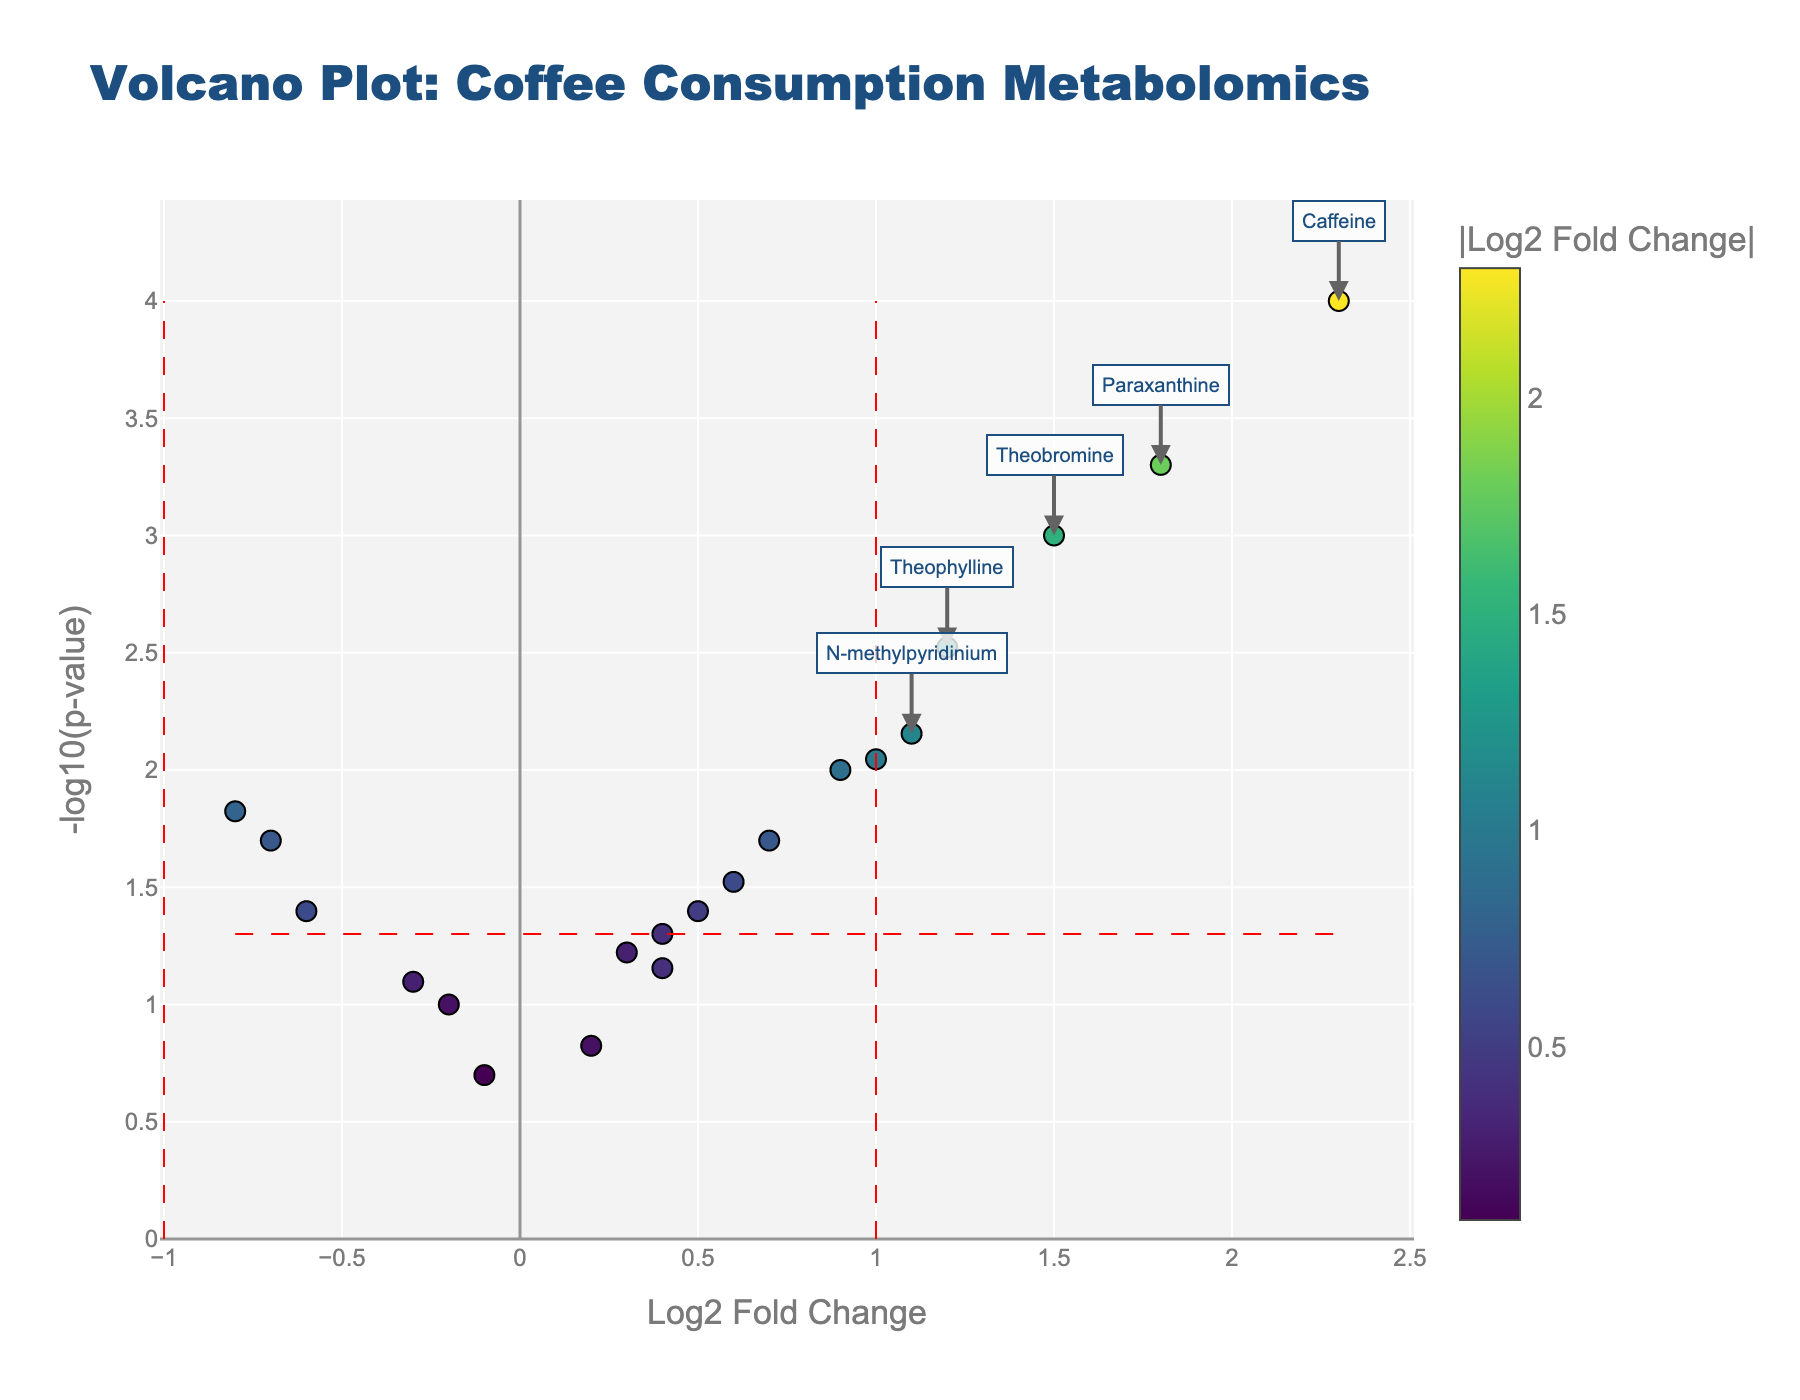What is the title of the Volcano Plot? The title of the Volcano Plot is located at the top of the figure, displayed in a large, bold font. It reads, "Volcano Plot: Coffee Consumption Metabolomics".
Answer: Volcano Plot: Coffee Consumption Metabolomics What is the x-axis labeled as? The x-axis label is located below the x-axis, indicating the variable it represents. It is labeled as "Log2 Fold Change".
Answer: Log2 Fold Change How many metabolites have a log2 fold change greater than 1? Look for metabolites with log2 fold change values greater than 1 on the x-axis. These points are mostly on the right side of the vertical line at x=1. By counting them, we find there are 5 metabolites.
Answer: 5 Which metabolite has the highest -log10(p-value)? Identify the point that reaches the highest point on the y-axis, representing the highest -log10(p-value). The metabolite with the highest -log10(p-value) is "Caffeine".
Answer: Caffeine Are there any metabolites with both a negative log2 fold change and a significant p-value (p < 0.05)? Identify points to the left of the vertical line at x=-1 (negative log2 fold change) and y value greater than 1.3 (-log10(p-value) corresponding to p < 0.05). By examining these points, "Trigonelline" and "Adenosine" meet these criteria.
Answer: Yes (Trigonelline, Adenosine) What's the average -log10(p-value) of metabolites with a positive log2 fold change? To find this, average the -log10(p-value) for metabolites to the right of the x=0 line (positive log2 fold change). The relevant metabolites and their values need adding up and dividing by their count based on the figure.
Answer: Approximately 1.417 (assuming labels and values on points shown are used) Which metabolite is located closest to the origin (0,0)? Look for the data point closest to both x=0 and y=0 on the plot. This point represents the metabolite with the smallest log2 fold change and p-value closest to 1. Based on visual inspection, it is "Potassium."
Answer: Potassium 